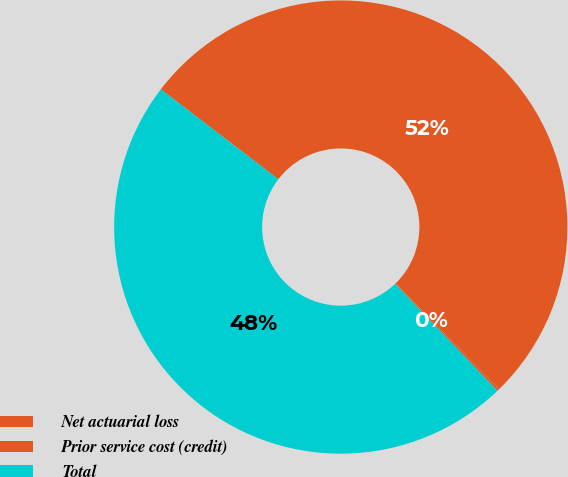<chart> <loc_0><loc_0><loc_500><loc_500><pie_chart><fcel>Net actuarial loss<fcel>Prior service cost (credit)<fcel>Total<nl><fcel>52.3%<fcel>0.16%<fcel>47.55%<nl></chart> 